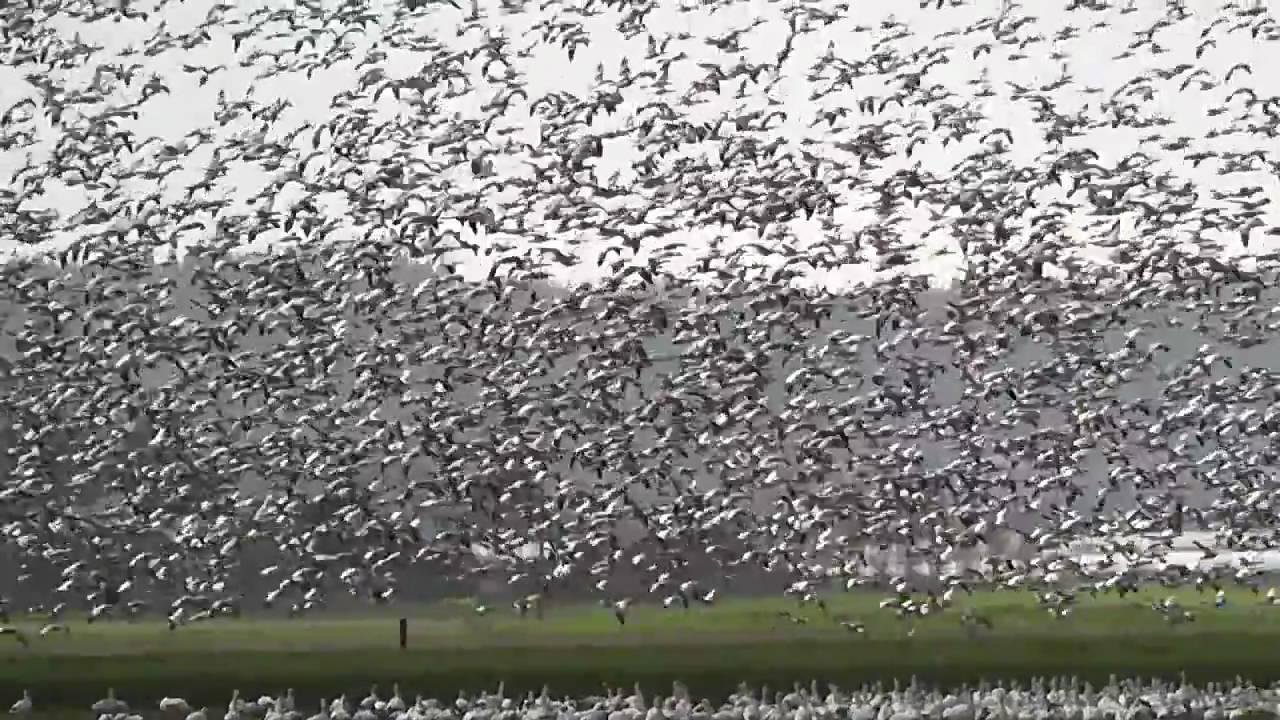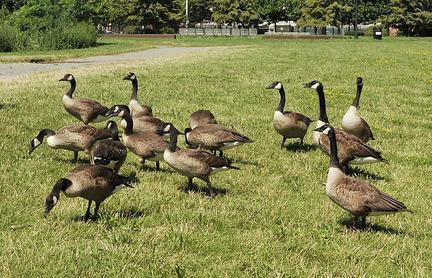The first image is the image on the left, the second image is the image on the right. Given the left and right images, does the statement "One of the images shows at least one cow standing in a field behind a flock of geese." hold true? Answer yes or no. No. The first image is the image on the left, the second image is the image on the right. Assess this claim about the two images: "An image includes at least one cow standing behind a flock of birds in a field.". Correct or not? Answer yes or no. No. 